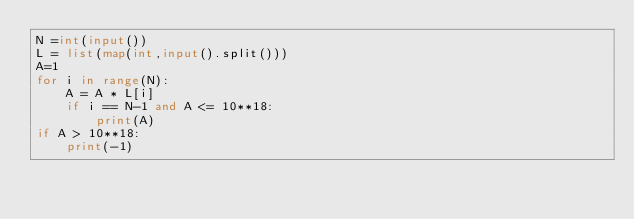Convert code to text. <code><loc_0><loc_0><loc_500><loc_500><_Python_>N =int(input())
L = list(map(int,input().split()))
A=1
for i in range(N):
    A = A * L[i]
    if i == N-1 and A <= 10**18:
        print(A)
if A > 10**18:
    print(-1)</code> 